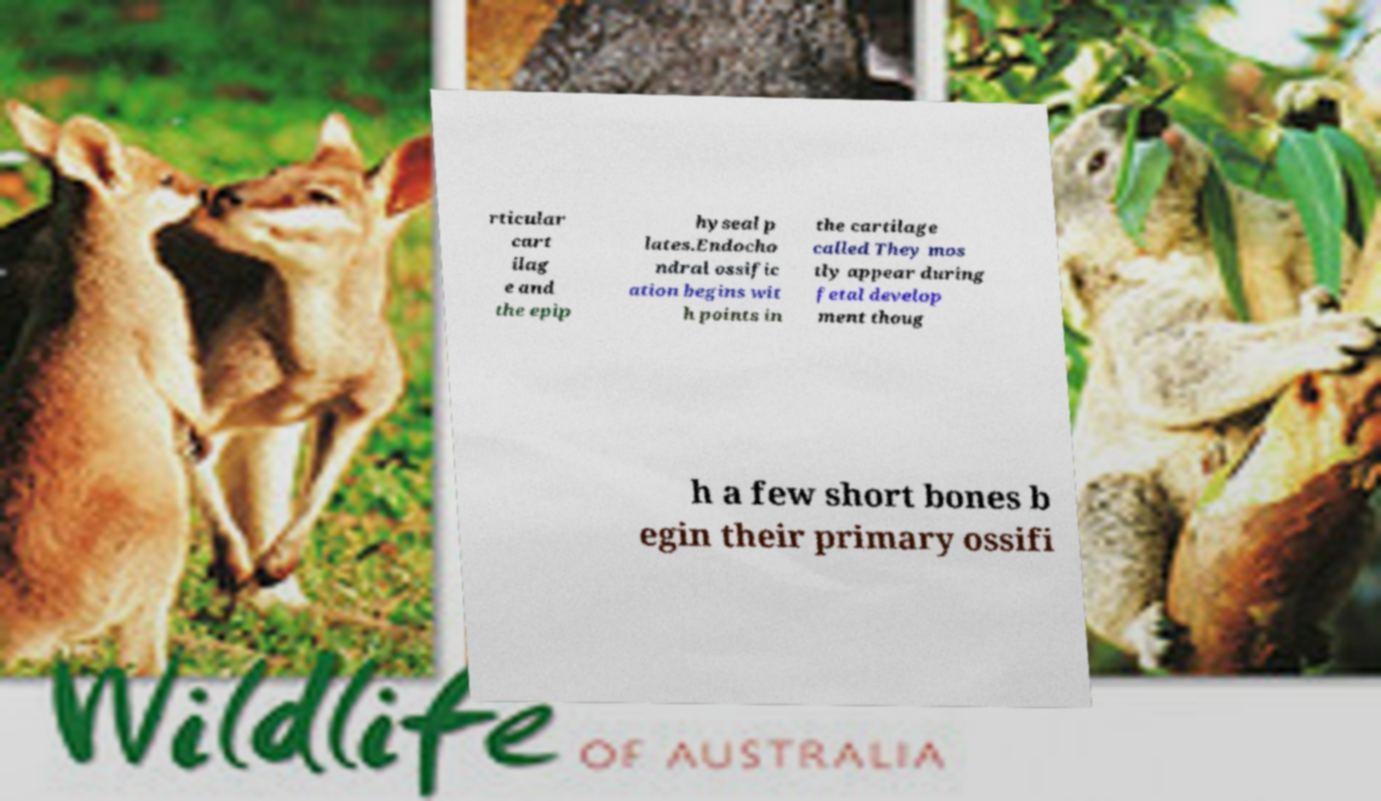Can you read and provide the text displayed in the image?This photo seems to have some interesting text. Can you extract and type it out for me? rticular cart ilag e and the epip hyseal p lates.Endocho ndral ossific ation begins wit h points in the cartilage called They mos tly appear during fetal develop ment thoug h a few short bones b egin their primary ossifi 